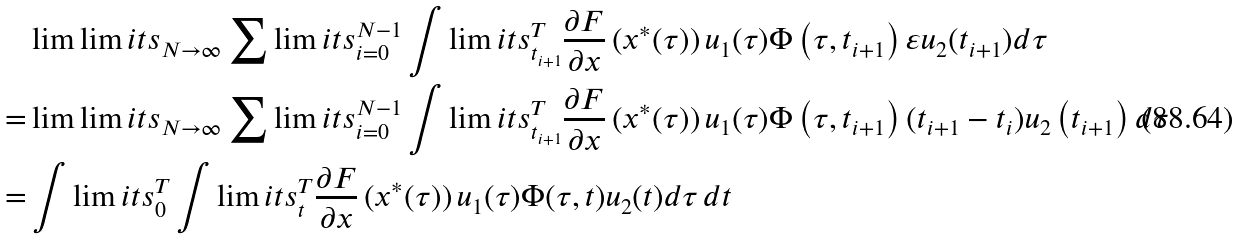Convert formula to latex. <formula><loc_0><loc_0><loc_500><loc_500>& \lim \lim i t s _ { N \to \infty } \sum \lim i t s _ { i = 0 } ^ { N - 1 } \int \lim i t s _ { t _ { i + 1 } } ^ { T } \frac { \partial F } { \partial x } \left ( x ^ { * } ( \tau ) \right ) u _ { 1 } ( \tau ) \Phi \left ( \tau , t _ { i + 1 } \right ) \varepsilon u _ { 2 } ( t _ { i + 1 } ) d \tau \\ = & \lim \lim i t s _ { N \to \infty } \sum \lim i t s _ { i = 0 } ^ { N - 1 } \int \lim i t s _ { t _ { i + 1 } } ^ { T } \frac { \partial F } { \partial x } \left ( x ^ { * } ( \tau ) \right ) u _ { 1 } ( \tau ) \Phi \left ( \tau , t _ { i + 1 } \right ) ( t _ { i + 1 } - t _ { i } ) u _ { 2 } \left ( t _ { i + 1 } \right ) d \tau \\ = & \int \lim i t s _ { 0 } ^ { T } \int \lim i t s _ { t } ^ { T } \frac { \partial F } { \partial x } \left ( x ^ { * } ( \tau ) \right ) u _ { 1 } ( \tau ) \Phi ( \tau , t ) u _ { 2 } ( t ) d \tau \, d t</formula> 